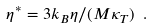Convert formula to latex. <formula><loc_0><loc_0><loc_500><loc_500>\eta ^ { * } = 3 k _ { B } \eta / ( M \kappa _ { T } ) \ .</formula> 